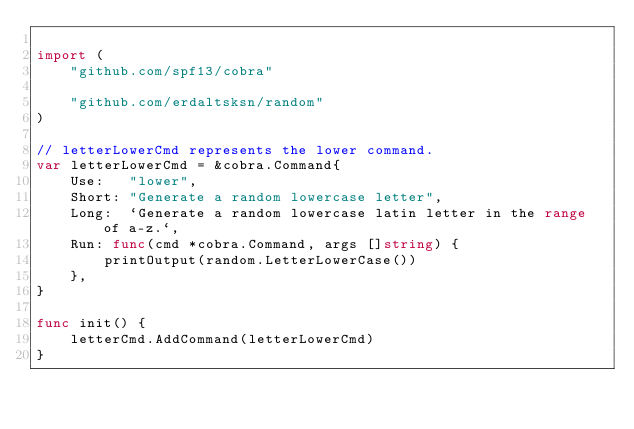Convert code to text. <code><loc_0><loc_0><loc_500><loc_500><_Go_>
import (
	"github.com/spf13/cobra"

	"github.com/erdaltsksn/random"
)

// letterLowerCmd represents the lower command.
var letterLowerCmd = &cobra.Command{
	Use:   "lower",
	Short: "Generate a random lowercase letter",
	Long:  `Generate a random lowercase latin letter in the range of a-z.`,
	Run: func(cmd *cobra.Command, args []string) {
		printOutput(random.LetterLowerCase())
	},
}

func init() {
	letterCmd.AddCommand(letterLowerCmd)
}
</code> 